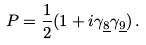<formula> <loc_0><loc_0><loc_500><loc_500>P = \frac { 1 } { 2 } ( 1 + i \gamma _ { \underline { 8 } } \gamma _ { \underline { 9 } } ) \, .</formula> 